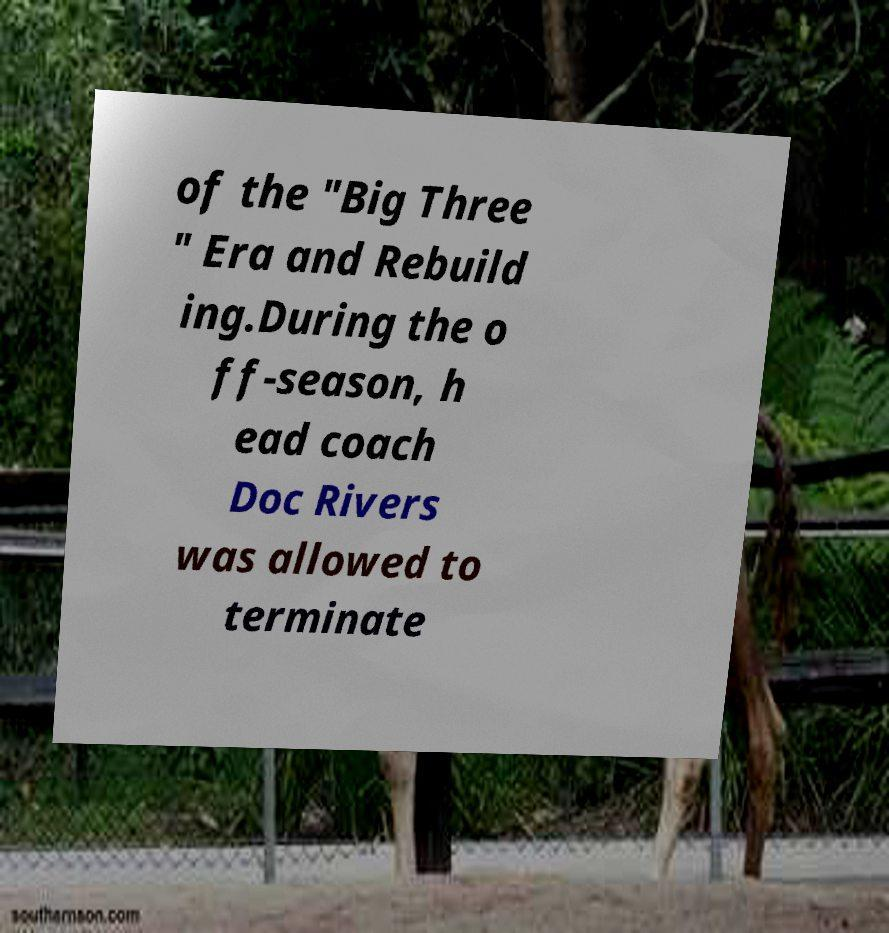Can you accurately transcribe the text from the provided image for me? of the "Big Three " Era and Rebuild ing.During the o ff-season, h ead coach Doc Rivers was allowed to terminate 